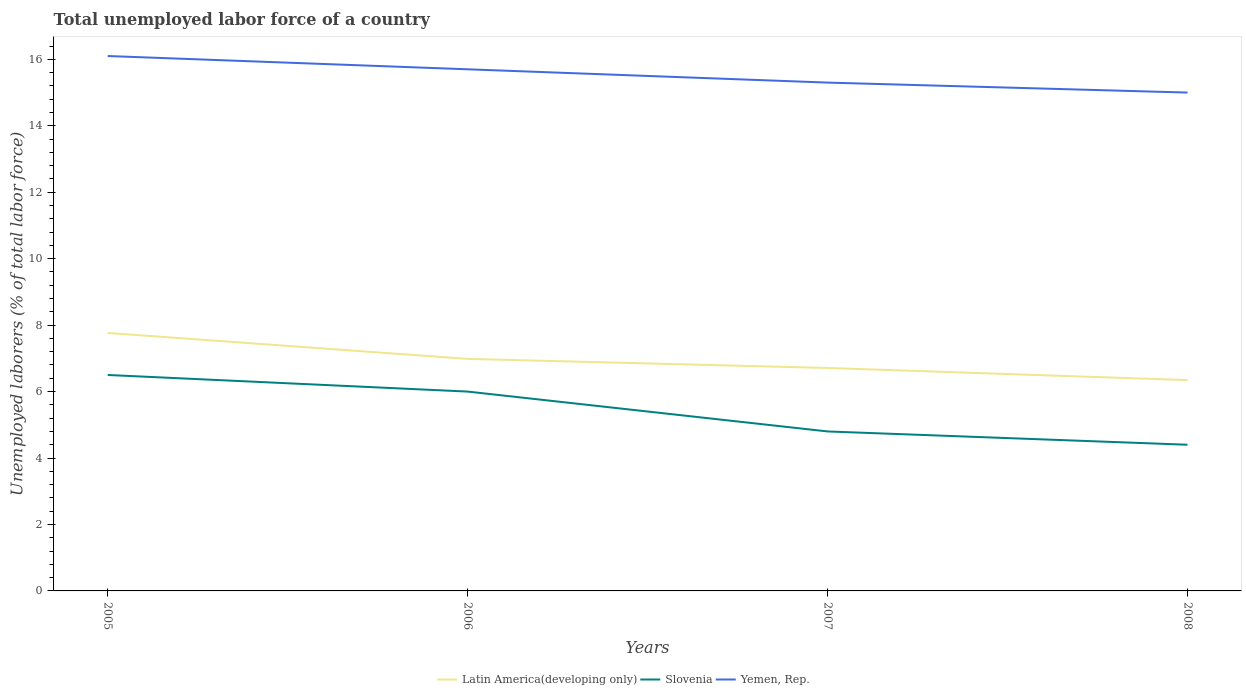How many different coloured lines are there?
Your response must be concise. 3. Does the line corresponding to Yemen, Rep. intersect with the line corresponding to Slovenia?
Your response must be concise. No. What is the total total unemployed labor force in Yemen, Rep. in the graph?
Keep it short and to the point. 0.4. What is the difference between the highest and the second highest total unemployed labor force in Yemen, Rep.?
Keep it short and to the point. 1.1. Is the total unemployed labor force in Latin America(developing only) strictly greater than the total unemployed labor force in Slovenia over the years?
Provide a succinct answer. No. How many lines are there?
Your answer should be compact. 3. How many years are there in the graph?
Ensure brevity in your answer.  4. Are the values on the major ticks of Y-axis written in scientific E-notation?
Give a very brief answer. No. Does the graph contain any zero values?
Your answer should be very brief. No. How are the legend labels stacked?
Offer a very short reply. Horizontal. What is the title of the graph?
Your answer should be very brief. Total unemployed labor force of a country. What is the label or title of the X-axis?
Make the answer very short. Years. What is the label or title of the Y-axis?
Your answer should be very brief. Unemployed laborers (% of total labor force). What is the Unemployed laborers (% of total labor force) of Latin America(developing only) in 2005?
Provide a succinct answer. 7.77. What is the Unemployed laborers (% of total labor force) in Slovenia in 2005?
Ensure brevity in your answer.  6.5. What is the Unemployed laborers (% of total labor force) in Yemen, Rep. in 2005?
Provide a succinct answer. 16.1. What is the Unemployed laborers (% of total labor force) in Latin America(developing only) in 2006?
Keep it short and to the point. 6.98. What is the Unemployed laborers (% of total labor force) of Yemen, Rep. in 2006?
Your answer should be very brief. 15.7. What is the Unemployed laborers (% of total labor force) in Latin America(developing only) in 2007?
Provide a short and direct response. 6.71. What is the Unemployed laborers (% of total labor force) of Slovenia in 2007?
Provide a succinct answer. 4.8. What is the Unemployed laborers (% of total labor force) of Yemen, Rep. in 2007?
Provide a succinct answer. 15.3. What is the Unemployed laborers (% of total labor force) of Latin America(developing only) in 2008?
Give a very brief answer. 6.35. What is the Unemployed laborers (% of total labor force) of Slovenia in 2008?
Offer a terse response. 4.4. Across all years, what is the maximum Unemployed laborers (% of total labor force) of Latin America(developing only)?
Make the answer very short. 7.77. Across all years, what is the maximum Unemployed laborers (% of total labor force) of Yemen, Rep.?
Give a very brief answer. 16.1. Across all years, what is the minimum Unemployed laborers (% of total labor force) of Latin America(developing only)?
Make the answer very short. 6.35. Across all years, what is the minimum Unemployed laborers (% of total labor force) in Slovenia?
Give a very brief answer. 4.4. Across all years, what is the minimum Unemployed laborers (% of total labor force) of Yemen, Rep.?
Offer a terse response. 15. What is the total Unemployed laborers (% of total labor force) of Latin America(developing only) in the graph?
Give a very brief answer. 27.8. What is the total Unemployed laborers (% of total labor force) of Slovenia in the graph?
Your answer should be very brief. 21.7. What is the total Unemployed laborers (% of total labor force) in Yemen, Rep. in the graph?
Provide a short and direct response. 62.1. What is the difference between the Unemployed laborers (% of total labor force) in Latin America(developing only) in 2005 and that in 2006?
Ensure brevity in your answer.  0.78. What is the difference between the Unemployed laborers (% of total labor force) of Yemen, Rep. in 2005 and that in 2006?
Provide a short and direct response. 0.4. What is the difference between the Unemployed laborers (% of total labor force) of Latin America(developing only) in 2005 and that in 2007?
Give a very brief answer. 1.05. What is the difference between the Unemployed laborers (% of total labor force) of Yemen, Rep. in 2005 and that in 2007?
Your response must be concise. 0.8. What is the difference between the Unemployed laborers (% of total labor force) in Latin America(developing only) in 2005 and that in 2008?
Your answer should be very brief. 1.42. What is the difference between the Unemployed laborers (% of total labor force) in Latin America(developing only) in 2006 and that in 2007?
Give a very brief answer. 0.27. What is the difference between the Unemployed laborers (% of total labor force) in Slovenia in 2006 and that in 2007?
Provide a succinct answer. 1.2. What is the difference between the Unemployed laborers (% of total labor force) in Latin America(developing only) in 2006 and that in 2008?
Provide a succinct answer. 0.64. What is the difference between the Unemployed laborers (% of total labor force) of Latin America(developing only) in 2007 and that in 2008?
Make the answer very short. 0.36. What is the difference between the Unemployed laborers (% of total labor force) of Slovenia in 2007 and that in 2008?
Provide a succinct answer. 0.4. What is the difference between the Unemployed laborers (% of total labor force) in Yemen, Rep. in 2007 and that in 2008?
Provide a short and direct response. 0.3. What is the difference between the Unemployed laborers (% of total labor force) of Latin America(developing only) in 2005 and the Unemployed laborers (% of total labor force) of Slovenia in 2006?
Ensure brevity in your answer.  1.77. What is the difference between the Unemployed laborers (% of total labor force) of Latin America(developing only) in 2005 and the Unemployed laborers (% of total labor force) of Yemen, Rep. in 2006?
Your answer should be very brief. -7.93. What is the difference between the Unemployed laborers (% of total labor force) of Latin America(developing only) in 2005 and the Unemployed laborers (% of total labor force) of Slovenia in 2007?
Make the answer very short. 2.97. What is the difference between the Unemployed laborers (% of total labor force) in Latin America(developing only) in 2005 and the Unemployed laborers (% of total labor force) in Yemen, Rep. in 2007?
Give a very brief answer. -7.53. What is the difference between the Unemployed laborers (% of total labor force) in Latin America(developing only) in 2005 and the Unemployed laborers (% of total labor force) in Slovenia in 2008?
Provide a succinct answer. 3.37. What is the difference between the Unemployed laborers (% of total labor force) in Latin America(developing only) in 2005 and the Unemployed laborers (% of total labor force) in Yemen, Rep. in 2008?
Provide a short and direct response. -7.23. What is the difference between the Unemployed laborers (% of total labor force) in Slovenia in 2005 and the Unemployed laborers (% of total labor force) in Yemen, Rep. in 2008?
Your response must be concise. -8.5. What is the difference between the Unemployed laborers (% of total labor force) in Latin America(developing only) in 2006 and the Unemployed laborers (% of total labor force) in Slovenia in 2007?
Provide a succinct answer. 2.18. What is the difference between the Unemployed laborers (% of total labor force) in Latin America(developing only) in 2006 and the Unemployed laborers (% of total labor force) in Yemen, Rep. in 2007?
Your response must be concise. -8.32. What is the difference between the Unemployed laborers (% of total labor force) of Slovenia in 2006 and the Unemployed laborers (% of total labor force) of Yemen, Rep. in 2007?
Keep it short and to the point. -9.3. What is the difference between the Unemployed laborers (% of total labor force) of Latin America(developing only) in 2006 and the Unemployed laborers (% of total labor force) of Slovenia in 2008?
Ensure brevity in your answer.  2.58. What is the difference between the Unemployed laborers (% of total labor force) in Latin America(developing only) in 2006 and the Unemployed laborers (% of total labor force) in Yemen, Rep. in 2008?
Your response must be concise. -8.02. What is the difference between the Unemployed laborers (% of total labor force) of Latin America(developing only) in 2007 and the Unemployed laborers (% of total labor force) of Slovenia in 2008?
Ensure brevity in your answer.  2.31. What is the difference between the Unemployed laborers (% of total labor force) in Latin America(developing only) in 2007 and the Unemployed laborers (% of total labor force) in Yemen, Rep. in 2008?
Your answer should be compact. -8.29. What is the difference between the Unemployed laborers (% of total labor force) of Slovenia in 2007 and the Unemployed laborers (% of total labor force) of Yemen, Rep. in 2008?
Your answer should be very brief. -10.2. What is the average Unemployed laborers (% of total labor force) in Latin America(developing only) per year?
Your answer should be very brief. 6.95. What is the average Unemployed laborers (% of total labor force) in Slovenia per year?
Give a very brief answer. 5.42. What is the average Unemployed laborers (% of total labor force) of Yemen, Rep. per year?
Your answer should be very brief. 15.53. In the year 2005, what is the difference between the Unemployed laborers (% of total labor force) of Latin America(developing only) and Unemployed laborers (% of total labor force) of Slovenia?
Offer a very short reply. 1.27. In the year 2005, what is the difference between the Unemployed laborers (% of total labor force) of Latin America(developing only) and Unemployed laborers (% of total labor force) of Yemen, Rep.?
Provide a succinct answer. -8.33. In the year 2005, what is the difference between the Unemployed laborers (% of total labor force) in Slovenia and Unemployed laborers (% of total labor force) in Yemen, Rep.?
Offer a very short reply. -9.6. In the year 2006, what is the difference between the Unemployed laborers (% of total labor force) in Latin America(developing only) and Unemployed laborers (% of total labor force) in Yemen, Rep.?
Your response must be concise. -8.72. In the year 2006, what is the difference between the Unemployed laborers (% of total labor force) in Slovenia and Unemployed laborers (% of total labor force) in Yemen, Rep.?
Make the answer very short. -9.7. In the year 2007, what is the difference between the Unemployed laborers (% of total labor force) in Latin America(developing only) and Unemployed laborers (% of total labor force) in Slovenia?
Offer a terse response. 1.91. In the year 2007, what is the difference between the Unemployed laborers (% of total labor force) of Latin America(developing only) and Unemployed laborers (% of total labor force) of Yemen, Rep.?
Keep it short and to the point. -8.59. In the year 2007, what is the difference between the Unemployed laborers (% of total labor force) in Slovenia and Unemployed laborers (% of total labor force) in Yemen, Rep.?
Offer a very short reply. -10.5. In the year 2008, what is the difference between the Unemployed laborers (% of total labor force) in Latin America(developing only) and Unemployed laborers (% of total labor force) in Slovenia?
Ensure brevity in your answer.  1.95. In the year 2008, what is the difference between the Unemployed laborers (% of total labor force) in Latin America(developing only) and Unemployed laborers (% of total labor force) in Yemen, Rep.?
Offer a terse response. -8.65. What is the ratio of the Unemployed laborers (% of total labor force) in Latin America(developing only) in 2005 to that in 2006?
Your response must be concise. 1.11. What is the ratio of the Unemployed laborers (% of total labor force) of Yemen, Rep. in 2005 to that in 2006?
Make the answer very short. 1.03. What is the ratio of the Unemployed laborers (% of total labor force) of Latin America(developing only) in 2005 to that in 2007?
Provide a succinct answer. 1.16. What is the ratio of the Unemployed laborers (% of total labor force) of Slovenia in 2005 to that in 2007?
Your response must be concise. 1.35. What is the ratio of the Unemployed laborers (% of total labor force) in Yemen, Rep. in 2005 to that in 2007?
Your answer should be very brief. 1.05. What is the ratio of the Unemployed laborers (% of total labor force) in Latin America(developing only) in 2005 to that in 2008?
Keep it short and to the point. 1.22. What is the ratio of the Unemployed laborers (% of total labor force) of Slovenia in 2005 to that in 2008?
Provide a succinct answer. 1.48. What is the ratio of the Unemployed laborers (% of total labor force) of Yemen, Rep. in 2005 to that in 2008?
Keep it short and to the point. 1.07. What is the ratio of the Unemployed laborers (% of total labor force) in Latin America(developing only) in 2006 to that in 2007?
Provide a short and direct response. 1.04. What is the ratio of the Unemployed laborers (% of total labor force) in Slovenia in 2006 to that in 2007?
Provide a succinct answer. 1.25. What is the ratio of the Unemployed laborers (% of total labor force) in Yemen, Rep. in 2006 to that in 2007?
Provide a succinct answer. 1.03. What is the ratio of the Unemployed laborers (% of total labor force) of Latin America(developing only) in 2006 to that in 2008?
Keep it short and to the point. 1.1. What is the ratio of the Unemployed laborers (% of total labor force) in Slovenia in 2006 to that in 2008?
Your answer should be very brief. 1.36. What is the ratio of the Unemployed laborers (% of total labor force) in Yemen, Rep. in 2006 to that in 2008?
Offer a terse response. 1.05. What is the ratio of the Unemployed laborers (% of total labor force) in Latin America(developing only) in 2007 to that in 2008?
Offer a terse response. 1.06. What is the ratio of the Unemployed laborers (% of total labor force) in Yemen, Rep. in 2007 to that in 2008?
Make the answer very short. 1.02. What is the difference between the highest and the second highest Unemployed laborers (% of total labor force) in Latin America(developing only)?
Give a very brief answer. 0.78. What is the difference between the highest and the lowest Unemployed laborers (% of total labor force) of Latin America(developing only)?
Your answer should be compact. 1.42. What is the difference between the highest and the lowest Unemployed laborers (% of total labor force) in Slovenia?
Provide a short and direct response. 2.1. 